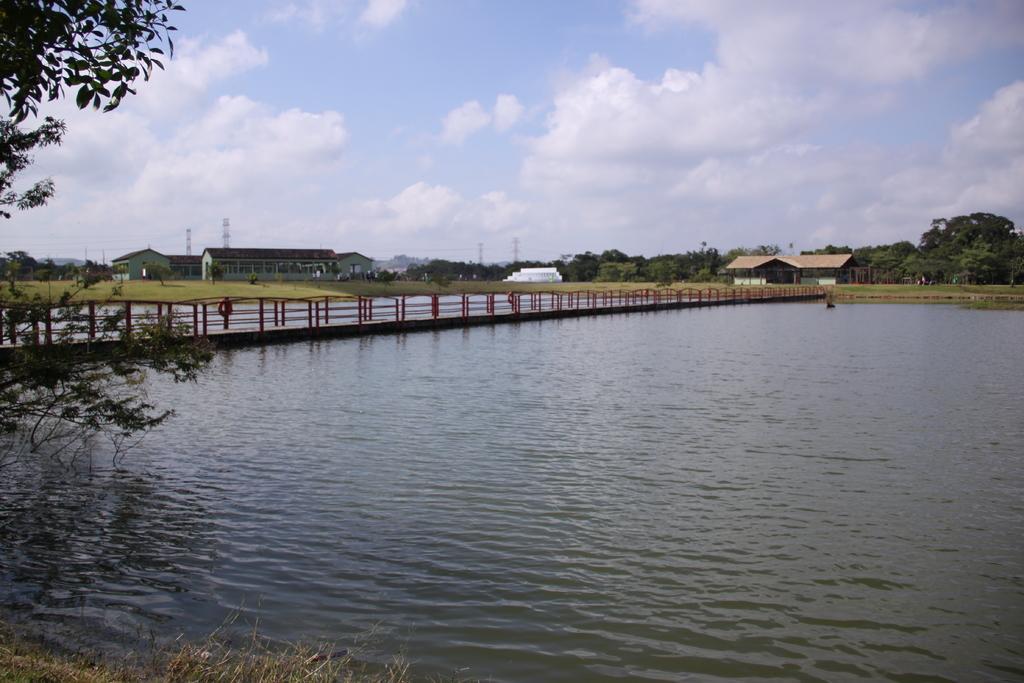Please provide a concise description of this image. In this image, we can see a water, bridge with rod fencing. At the bottom, we can see grass. Here we can see few trees, houses, towers. Top of the image, there is a cloudy sky. 